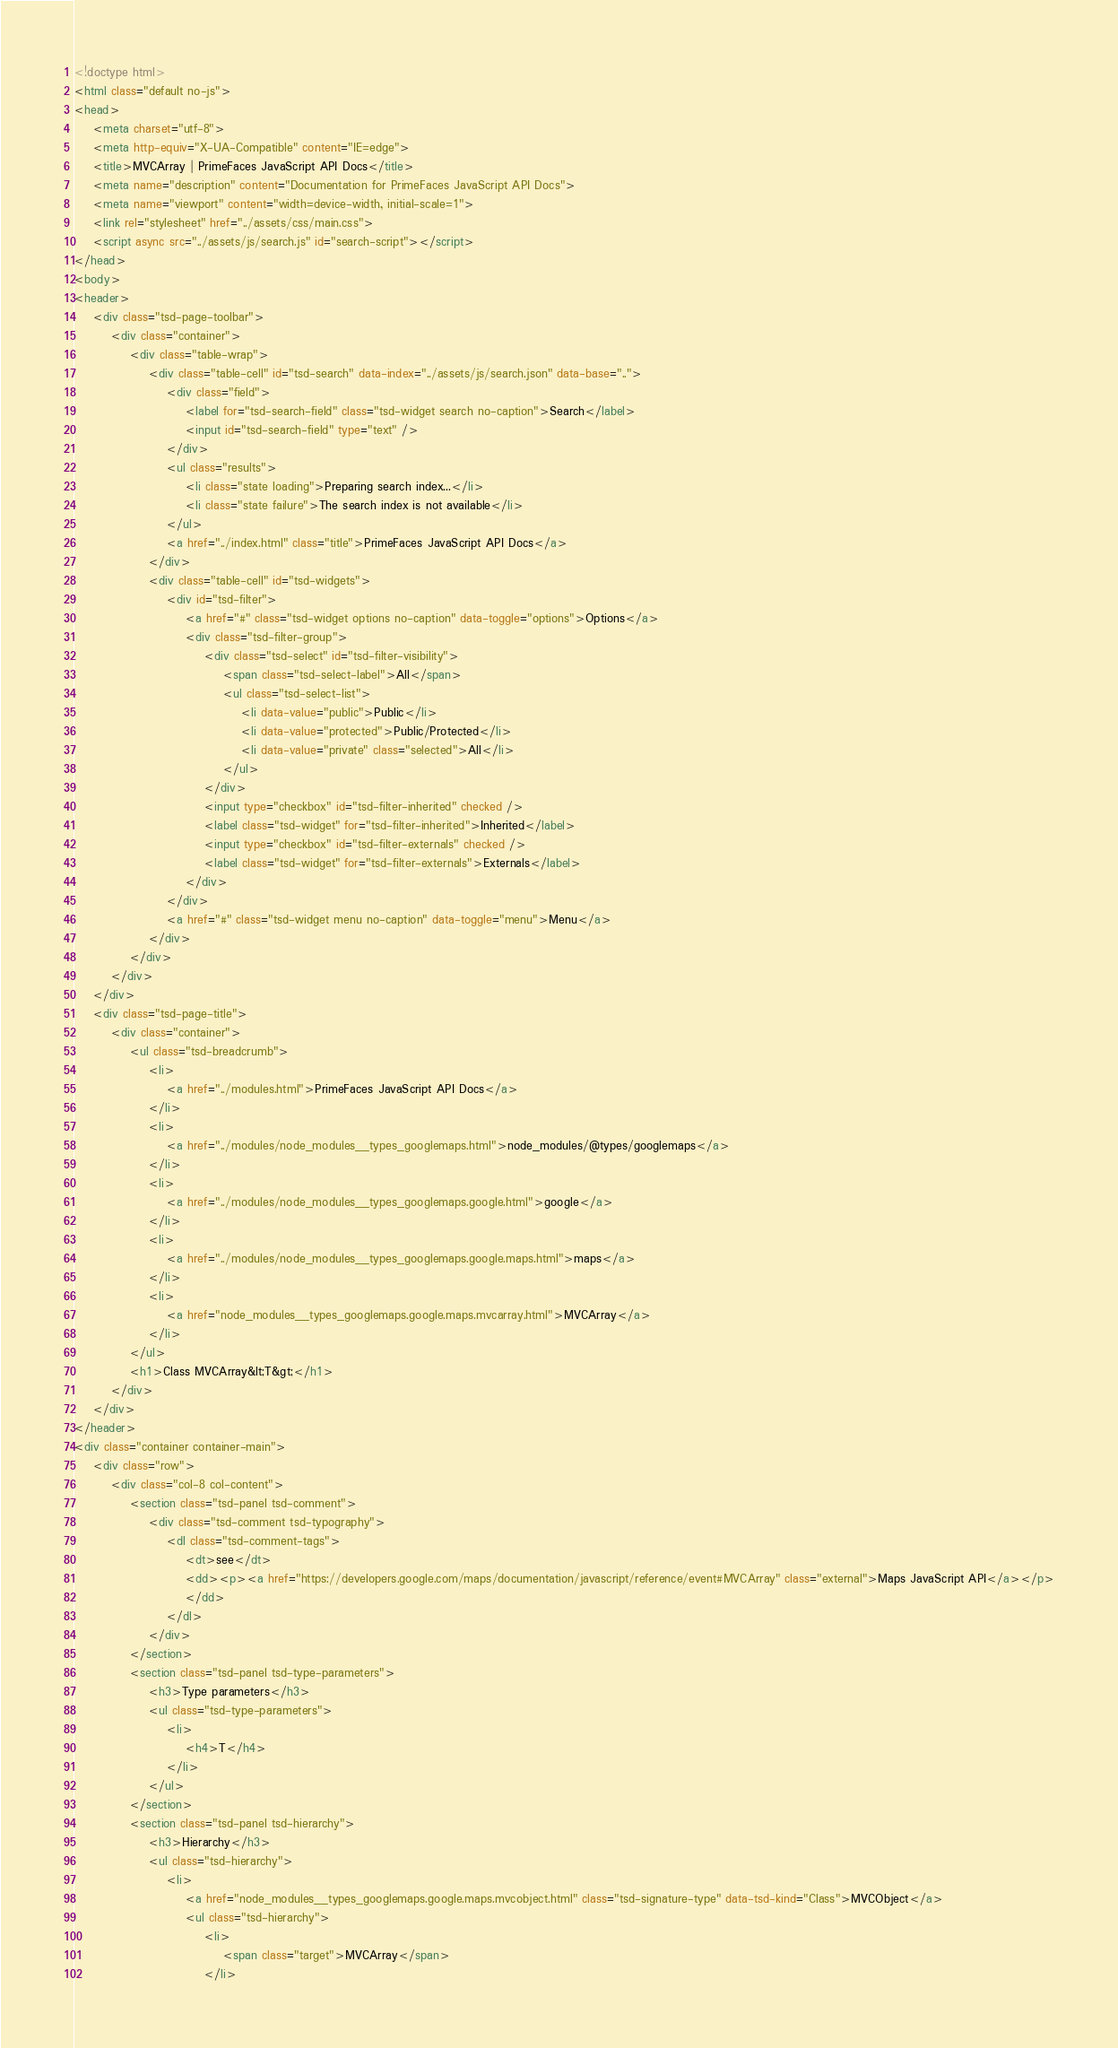Convert code to text. <code><loc_0><loc_0><loc_500><loc_500><_HTML_><!doctype html>
<html class="default no-js">
<head>
	<meta charset="utf-8">
	<meta http-equiv="X-UA-Compatible" content="IE=edge">
	<title>MVCArray | PrimeFaces JavaScript API Docs</title>
	<meta name="description" content="Documentation for PrimeFaces JavaScript API Docs">
	<meta name="viewport" content="width=device-width, initial-scale=1">
	<link rel="stylesheet" href="../assets/css/main.css">
	<script async src="../assets/js/search.js" id="search-script"></script>
</head>
<body>
<header>
	<div class="tsd-page-toolbar">
		<div class="container">
			<div class="table-wrap">
				<div class="table-cell" id="tsd-search" data-index="../assets/js/search.json" data-base="..">
					<div class="field">
						<label for="tsd-search-field" class="tsd-widget search no-caption">Search</label>
						<input id="tsd-search-field" type="text" />
					</div>
					<ul class="results">
						<li class="state loading">Preparing search index...</li>
						<li class="state failure">The search index is not available</li>
					</ul>
					<a href="../index.html" class="title">PrimeFaces JavaScript API Docs</a>
				</div>
				<div class="table-cell" id="tsd-widgets">
					<div id="tsd-filter">
						<a href="#" class="tsd-widget options no-caption" data-toggle="options">Options</a>
						<div class="tsd-filter-group">
							<div class="tsd-select" id="tsd-filter-visibility">
								<span class="tsd-select-label">All</span>
								<ul class="tsd-select-list">
									<li data-value="public">Public</li>
									<li data-value="protected">Public/Protected</li>
									<li data-value="private" class="selected">All</li>
								</ul>
							</div>
							<input type="checkbox" id="tsd-filter-inherited" checked />
							<label class="tsd-widget" for="tsd-filter-inherited">Inherited</label>
							<input type="checkbox" id="tsd-filter-externals" checked />
							<label class="tsd-widget" for="tsd-filter-externals">Externals</label>
						</div>
					</div>
					<a href="#" class="tsd-widget menu no-caption" data-toggle="menu">Menu</a>
				</div>
			</div>
		</div>
	</div>
	<div class="tsd-page-title">
		<div class="container">
			<ul class="tsd-breadcrumb">
				<li>
					<a href="../modules.html">PrimeFaces JavaScript API Docs</a>
				</li>
				<li>
					<a href="../modules/node_modules__types_googlemaps.html">node_modules/@types/googlemaps</a>
				</li>
				<li>
					<a href="../modules/node_modules__types_googlemaps.google.html">google</a>
				</li>
				<li>
					<a href="../modules/node_modules__types_googlemaps.google.maps.html">maps</a>
				</li>
				<li>
					<a href="node_modules__types_googlemaps.google.maps.mvcarray.html">MVCArray</a>
				</li>
			</ul>
			<h1>Class MVCArray&lt;T&gt;</h1>
		</div>
	</div>
</header>
<div class="container container-main">
	<div class="row">
		<div class="col-8 col-content">
			<section class="tsd-panel tsd-comment">
				<div class="tsd-comment tsd-typography">
					<dl class="tsd-comment-tags">
						<dt>see</dt>
						<dd><p><a href="https://developers.google.com/maps/documentation/javascript/reference/event#MVCArray" class="external">Maps JavaScript API</a></p>
						</dd>
					</dl>
				</div>
			</section>
			<section class="tsd-panel tsd-type-parameters">
				<h3>Type parameters</h3>
				<ul class="tsd-type-parameters">
					<li>
						<h4>T</h4>
					</li>
				</ul>
			</section>
			<section class="tsd-panel tsd-hierarchy">
				<h3>Hierarchy</h3>
				<ul class="tsd-hierarchy">
					<li>
						<a href="node_modules__types_googlemaps.google.maps.mvcobject.html" class="tsd-signature-type" data-tsd-kind="Class">MVCObject</a>
						<ul class="tsd-hierarchy">
							<li>
								<span class="target">MVCArray</span>
							</li></code> 